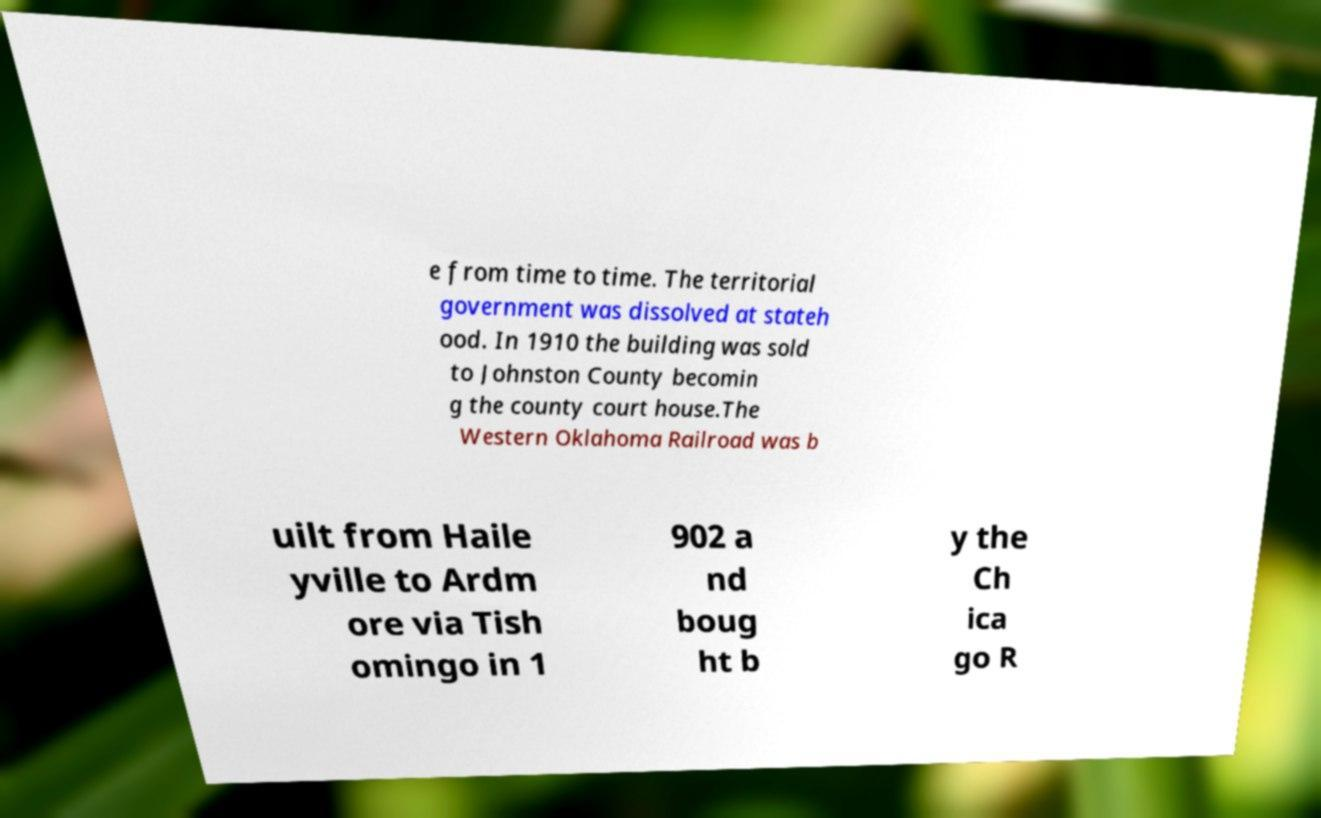I need the written content from this picture converted into text. Can you do that? e from time to time. The territorial government was dissolved at stateh ood. In 1910 the building was sold to Johnston County becomin g the county court house.The Western Oklahoma Railroad was b uilt from Haile yville to Ardm ore via Tish omingo in 1 902 a nd boug ht b y the Ch ica go R 